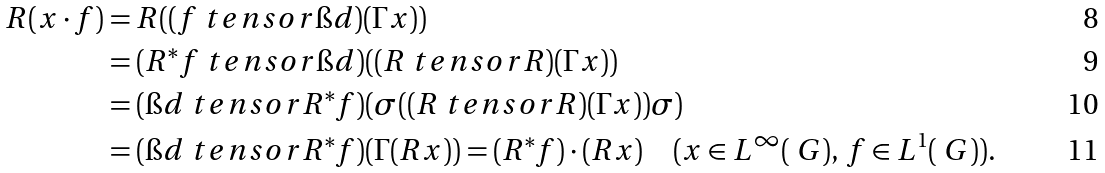<formula> <loc_0><loc_0><loc_500><loc_500>R ( x \cdot f ) & = R ( ( f \ t e n s o r \i d ) ( \Gamma x ) ) \\ & = ( R ^ { \ast } f \ t e n s o r \i d ) ( ( R \ t e n s o r R ) ( \Gamma x ) ) \\ & = ( \i d \ t e n s o r R ^ { \ast } f ) ( \sigma ( ( R \ t e n s o r R ) ( \Gamma x ) ) \sigma ) \\ & = ( \i d \ t e n s o r R ^ { \ast } f ) ( \Gamma ( R x ) ) = ( R ^ { \ast } f ) \cdot ( R x ) \quad ( x \in L ^ { \infty } ( \ G ) , \, f \in L ^ { 1 } ( \ G ) ) .</formula> 